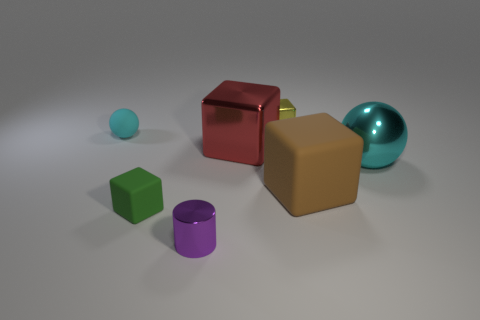Subtract all yellow blocks. How many blocks are left? 3 Subtract 1 blocks. How many blocks are left? 3 Add 1 cyan metal balls. How many objects exist? 8 Subtract all green blocks. How many blocks are left? 3 Subtract all cubes. How many objects are left? 3 Subtract all cyan cubes. Subtract all purple cylinders. How many cubes are left? 4 Add 2 large purple matte blocks. How many large purple matte blocks exist? 2 Subtract 0 purple spheres. How many objects are left? 7 Subtract all small green rubber blocks. Subtract all small purple metallic cylinders. How many objects are left? 5 Add 4 rubber things. How many rubber things are left? 7 